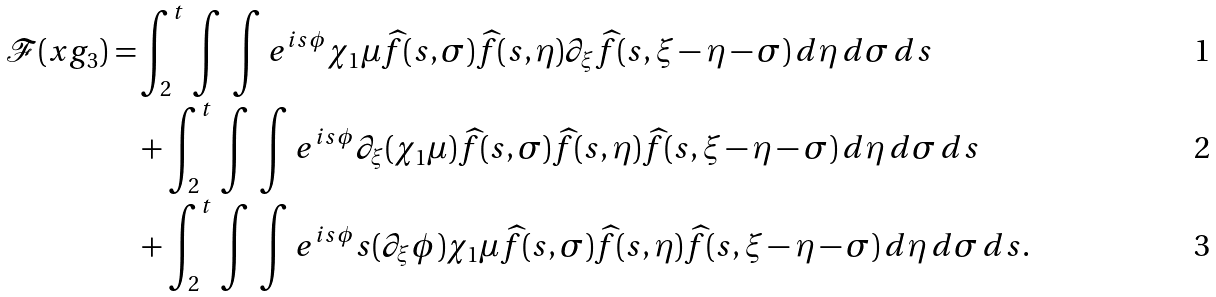Convert formula to latex. <formula><loc_0><loc_0><loc_500><loc_500>\mathcal { F } ( x g _ { 3 } ) = & \int _ { 2 } ^ { t } \, \int \, \int e ^ { i s \phi } \chi _ { 1 } \mu \widehat { f } ( s , \sigma ) \widehat { f } ( s , \eta ) \partial _ { \xi } \widehat { f } ( s , \xi - \eta - \sigma ) \, d \eta \, d \sigma \, d s \\ & + \int _ { 2 } ^ { t } \, \int \, \int e ^ { i s \phi } \partial _ { \xi } ( \chi _ { 1 } \mu ) \widehat { f } ( s , \sigma ) \widehat { f } ( s , \eta ) \widehat { f } ( s , \xi - \eta - \sigma ) \, d \eta \, d \sigma \, d s \\ & + \int _ { 2 } ^ { t } \, \int \, \int e ^ { i s \phi } s ( \partial _ { \xi } \phi ) \chi _ { 1 } \mu \widehat { f } ( s , \sigma ) \widehat { f } ( s , \eta ) \widehat { f } ( s , \xi - \eta - \sigma ) \, d \eta \, d \sigma \, d s .</formula> 